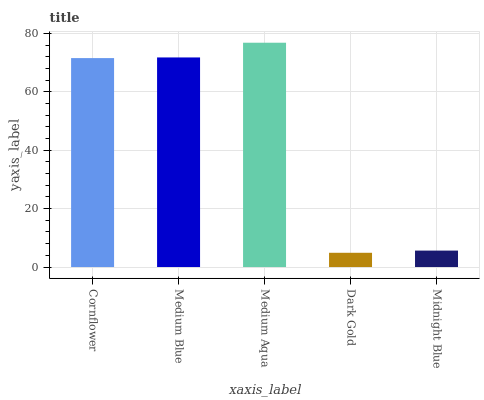Is Dark Gold the minimum?
Answer yes or no. Yes. Is Medium Aqua the maximum?
Answer yes or no. Yes. Is Medium Blue the minimum?
Answer yes or no. No. Is Medium Blue the maximum?
Answer yes or no. No. Is Medium Blue greater than Cornflower?
Answer yes or no. Yes. Is Cornflower less than Medium Blue?
Answer yes or no. Yes. Is Cornflower greater than Medium Blue?
Answer yes or no. No. Is Medium Blue less than Cornflower?
Answer yes or no. No. Is Cornflower the high median?
Answer yes or no. Yes. Is Cornflower the low median?
Answer yes or no. Yes. Is Medium Aqua the high median?
Answer yes or no. No. Is Dark Gold the low median?
Answer yes or no. No. 